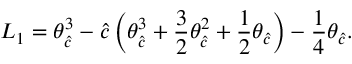<formula> <loc_0><loc_0><loc_500><loc_500>L _ { 1 } = \theta _ { \hat { c } } ^ { 3 } - { \hat { c } } \left ( \theta _ { \hat { c } } ^ { 3 } + \frac { 3 } { 2 } \theta _ { \hat { c } } ^ { 2 } + \frac { 1 } { 2 } \theta _ { \hat { c } } \right ) - \frac { 1 } { 4 } \theta _ { \hat { c } } .</formula> 